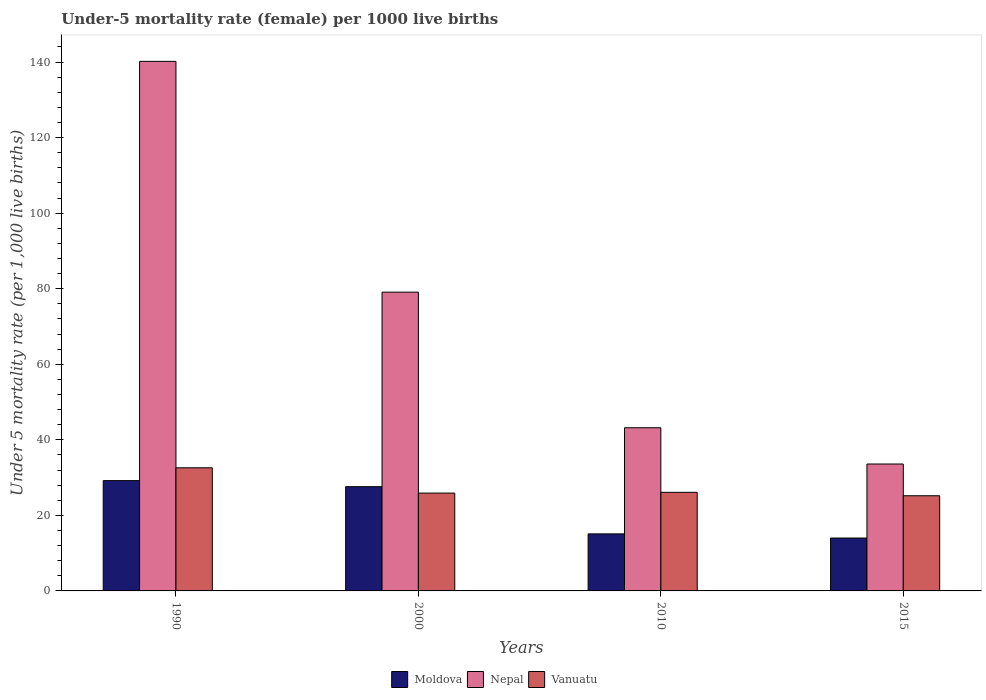How many bars are there on the 1st tick from the right?
Offer a very short reply. 3. In how many cases, is the number of bars for a given year not equal to the number of legend labels?
Your response must be concise. 0. What is the under-five mortality rate in Vanuatu in 2000?
Your answer should be very brief. 25.9. Across all years, what is the maximum under-five mortality rate in Vanuatu?
Make the answer very short. 32.6. Across all years, what is the minimum under-five mortality rate in Nepal?
Keep it short and to the point. 33.6. In which year was the under-five mortality rate in Nepal maximum?
Offer a very short reply. 1990. In which year was the under-five mortality rate in Moldova minimum?
Ensure brevity in your answer.  2015. What is the total under-five mortality rate in Vanuatu in the graph?
Your answer should be very brief. 109.8. What is the difference between the under-five mortality rate in Nepal in 1990 and that in 2015?
Keep it short and to the point. 106.6. What is the difference between the under-five mortality rate in Moldova in 2010 and the under-five mortality rate in Vanuatu in 2015?
Your response must be concise. -10.1. What is the average under-five mortality rate in Moldova per year?
Keep it short and to the point. 21.47. In the year 2015, what is the difference between the under-five mortality rate in Vanuatu and under-five mortality rate in Nepal?
Ensure brevity in your answer.  -8.4. What is the ratio of the under-five mortality rate in Moldova in 2000 to that in 2015?
Ensure brevity in your answer.  1.97. What is the difference between the highest and the second highest under-five mortality rate in Moldova?
Provide a succinct answer. 1.6. What is the difference between the highest and the lowest under-five mortality rate in Moldova?
Your answer should be compact. 15.2. In how many years, is the under-five mortality rate in Moldova greater than the average under-five mortality rate in Moldova taken over all years?
Provide a short and direct response. 2. Is the sum of the under-five mortality rate in Nepal in 1990 and 2015 greater than the maximum under-five mortality rate in Vanuatu across all years?
Provide a succinct answer. Yes. What does the 2nd bar from the left in 2015 represents?
Provide a short and direct response. Nepal. What does the 2nd bar from the right in 1990 represents?
Your answer should be very brief. Nepal. Are all the bars in the graph horizontal?
Make the answer very short. No. Are the values on the major ticks of Y-axis written in scientific E-notation?
Offer a terse response. No. Does the graph contain grids?
Give a very brief answer. No. Where does the legend appear in the graph?
Provide a succinct answer. Bottom center. How are the legend labels stacked?
Make the answer very short. Horizontal. What is the title of the graph?
Your response must be concise. Under-5 mortality rate (female) per 1000 live births. Does "Senegal" appear as one of the legend labels in the graph?
Provide a succinct answer. No. What is the label or title of the X-axis?
Offer a terse response. Years. What is the label or title of the Y-axis?
Keep it short and to the point. Under 5 mortality rate (per 1,0 live births). What is the Under 5 mortality rate (per 1,000 live births) in Moldova in 1990?
Offer a terse response. 29.2. What is the Under 5 mortality rate (per 1,000 live births) of Nepal in 1990?
Provide a short and direct response. 140.2. What is the Under 5 mortality rate (per 1,000 live births) in Vanuatu in 1990?
Give a very brief answer. 32.6. What is the Under 5 mortality rate (per 1,000 live births) of Moldova in 2000?
Your answer should be very brief. 27.6. What is the Under 5 mortality rate (per 1,000 live births) in Nepal in 2000?
Ensure brevity in your answer.  79.1. What is the Under 5 mortality rate (per 1,000 live births) of Vanuatu in 2000?
Give a very brief answer. 25.9. What is the Under 5 mortality rate (per 1,000 live births) in Nepal in 2010?
Your answer should be very brief. 43.2. What is the Under 5 mortality rate (per 1,000 live births) in Vanuatu in 2010?
Keep it short and to the point. 26.1. What is the Under 5 mortality rate (per 1,000 live births) of Moldova in 2015?
Provide a succinct answer. 14. What is the Under 5 mortality rate (per 1,000 live births) in Nepal in 2015?
Provide a short and direct response. 33.6. What is the Under 5 mortality rate (per 1,000 live births) in Vanuatu in 2015?
Provide a short and direct response. 25.2. Across all years, what is the maximum Under 5 mortality rate (per 1,000 live births) in Moldova?
Ensure brevity in your answer.  29.2. Across all years, what is the maximum Under 5 mortality rate (per 1,000 live births) of Nepal?
Give a very brief answer. 140.2. Across all years, what is the maximum Under 5 mortality rate (per 1,000 live births) in Vanuatu?
Keep it short and to the point. 32.6. Across all years, what is the minimum Under 5 mortality rate (per 1,000 live births) in Nepal?
Offer a very short reply. 33.6. Across all years, what is the minimum Under 5 mortality rate (per 1,000 live births) of Vanuatu?
Offer a terse response. 25.2. What is the total Under 5 mortality rate (per 1,000 live births) in Moldova in the graph?
Keep it short and to the point. 85.9. What is the total Under 5 mortality rate (per 1,000 live births) in Nepal in the graph?
Make the answer very short. 296.1. What is the total Under 5 mortality rate (per 1,000 live births) of Vanuatu in the graph?
Your response must be concise. 109.8. What is the difference between the Under 5 mortality rate (per 1,000 live births) in Nepal in 1990 and that in 2000?
Provide a succinct answer. 61.1. What is the difference between the Under 5 mortality rate (per 1,000 live births) of Moldova in 1990 and that in 2010?
Provide a succinct answer. 14.1. What is the difference between the Under 5 mortality rate (per 1,000 live births) of Nepal in 1990 and that in 2010?
Offer a terse response. 97. What is the difference between the Under 5 mortality rate (per 1,000 live births) in Vanuatu in 1990 and that in 2010?
Provide a short and direct response. 6.5. What is the difference between the Under 5 mortality rate (per 1,000 live births) of Moldova in 1990 and that in 2015?
Give a very brief answer. 15.2. What is the difference between the Under 5 mortality rate (per 1,000 live births) of Nepal in 1990 and that in 2015?
Provide a short and direct response. 106.6. What is the difference between the Under 5 mortality rate (per 1,000 live births) in Vanuatu in 1990 and that in 2015?
Give a very brief answer. 7.4. What is the difference between the Under 5 mortality rate (per 1,000 live births) of Moldova in 2000 and that in 2010?
Provide a succinct answer. 12.5. What is the difference between the Under 5 mortality rate (per 1,000 live births) in Nepal in 2000 and that in 2010?
Offer a terse response. 35.9. What is the difference between the Under 5 mortality rate (per 1,000 live births) of Vanuatu in 2000 and that in 2010?
Your answer should be compact. -0.2. What is the difference between the Under 5 mortality rate (per 1,000 live births) of Nepal in 2000 and that in 2015?
Offer a terse response. 45.5. What is the difference between the Under 5 mortality rate (per 1,000 live births) in Moldova in 1990 and the Under 5 mortality rate (per 1,000 live births) in Nepal in 2000?
Ensure brevity in your answer.  -49.9. What is the difference between the Under 5 mortality rate (per 1,000 live births) of Moldova in 1990 and the Under 5 mortality rate (per 1,000 live births) of Vanuatu in 2000?
Make the answer very short. 3.3. What is the difference between the Under 5 mortality rate (per 1,000 live births) of Nepal in 1990 and the Under 5 mortality rate (per 1,000 live births) of Vanuatu in 2000?
Provide a succinct answer. 114.3. What is the difference between the Under 5 mortality rate (per 1,000 live births) of Moldova in 1990 and the Under 5 mortality rate (per 1,000 live births) of Vanuatu in 2010?
Your answer should be compact. 3.1. What is the difference between the Under 5 mortality rate (per 1,000 live births) in Nepal in 1990 and the Under 5 mortality rate (per 1,000 live births) in Vanuatu in 2010?
Keep it short and to the point. 114.1. What is the difference between the Under 5 mortality rate (per 1,000 live births) of Moldova in 1990 and the Under 5 mortality rate (per 1,000 live births) of Vanuatu in 2015?
Offer a very short reply. 4. What is the difference between the Under 5 mortality rate (per 1,000 live births) of Nepal in 1990 and the Under 5 mortality rate (per 1,000 live births) of Vanuatu in 2015?
Your answer should be very brief. 115. What is the difference between the Under 5 mortality rate (per 1,000 live births) in Moldova in 2000 and the Under 5 mortality rate (per 1,000 live births) in Nepal in 2010?
Offer a very short reply. -15.6. What is the difference between the Under 5 mortality rate (per 1,000 live births) of Nepal in 2000 and the Under 5 mortality rate (per 1,000 live births) of Vanuatu in 2010?
Keep it short and to the point. 53. What is the difference between the Under 5 mortality rate (per 1,000 live births) in Nepal in 2000 and the Under 5 mortality rate (per 1,000 live births) in Vanuatu in 2015?
Your answer should be compact. 53.9. What is the difference between the Under 5 mortality rate (per 1,000 live births) in Moldova in 2010 and the Under 5 mortality rate (per 1,000 live births) in Nepal in 2015?
Your answer should be compact. -18.5. What is the average Under 5 mortality rate (per 1,000 live births) in Moldova per year?
Ensure brevity in your answer.  21.48. What is the average Under 5 mortality rate (per 1,000 live births) of Nepal per year?
Offer a terse response. 74.03. What is the average Under 5 mortality rate (per 1,000 live births) of Vanuatu per year?
Provide a succinct answer. 27.45. In the year 1990, what is the difference between the Under 5 mortality rate (per 1,000 live births) in Moldova and Under 5 mortality rate (per 1,000 live births) in Nepal?
Give a very brief answer. -111. In the year 1990, what is the difference between the Under 5 mortality rate (per 1,000 live births) of Moldova and Under 5 mortality rate (per 1,000 live births) of Vanuatu?
Provide a short and direct response. -3.4. In the year 1990, what is the difference between the Under 5 mortality rate (per 1,000 live births) of Nepal and Under 5 mortality rate (per 1,000 live births) of Vanuatu?
Your answer should be very brief. 107.6. In the year 2000, what is the difference between the Under 5 mortality rate (per 1,000 live births) of Moldova and Under 5 mortality rate (per 1,000 live births) of Nepal?
Offer a very short reply. -51.5. In the year 2000, what is the difference between the Under 5 mortality rate (per 1,000 live births) in Nepal and Under 5 mortality rate (per 1,000 live births) in Vanuatu?
Your answer should be very brief. 53.2. In the year 2010, what is the difference between the Under 5 mortality rate (per 1,000 live births) of Moldova and Under 5 mortality rate (per 1,000 live births) of Nepal?
Offer a terse response. -28.1. In the year 2010, what is the difference between the Under 5 mortality rate (per 1,000 live births) of Moldova and Under 5 mortality rate (per 1,000 live births) of Vanuatu?
Give a very brief answer. -11. In the year 2015, what is the difference between the Under 5 mortality rate (per 1,000 live births) of Moldova and Under 5 mortality rate (per 1,000 live births) of Nepal?
Keep it short and to the point. -19.6. In the year 2015, what is the difference between the Under 5 mortality rate (per 1,000 live births) in Moldova and Under 5 mortality rate (per 1,000 live births) in Vanuatu?
Offer a terse response. -11.2. In the year 2015, what is the difference between the Under 5 mortality rate (per 1,000 live births) of Nepal and Under 5 mortality rate (per 1,000 live births) of Vanuatu?
Keep it short and to the point. 8.4. What is the ratio of the Under 5 mortality rate (per 1,000 live births) of Moldova in 1990 to that in 2000?
Keep it short and to the point. 1.06. What is the ratio of the Under 5 mortality rate (per 1,000 live births) in Nepal in 1990 to that in 2000?
Make the answer very short. 1.77. What is the ratio of the Under 5 mortality rate (per 1,000 live births) of Vanuatu in 1990 to that in 2000?
Provide a succinct answer. 1.26. What is the ratio of the Under 5 mortality rate (per 1,000 live births) of Moldova in 1990 to that in 2010?
Your answer should be compact. 1.93. What is the ratio of the Under 5 mortality rate (per 1,000 live births) in Nepal in 1990 to that in 2010?
Offer a terse response. 3.25. What is the ratio of the Under 5 mortality rate (per 1,000 live births) of Vanuatu in 1990 to that in 2010?
Provide a short and direct response. 1.25. What is the ratio of the Under 5 mortality rate (per 1,000 live births) of Moldova in 1990 to that in 2015?
Your response must be concise. 2.09. What is the ratio of the Under 5 mortality rate (per 1,000 live births) of Nepal in 1990 to that in 2015?
Your answer should be very brief. 4.17. What is the ratio of the Under 5 mortality rate (per 1,000 live births) in Vanuatu in 1990 to that in 2015?
Make the answer very short. 1.29. What is the ratio of the Under 5 mortality rate (per 1,000 live births) in Moldova in 2000 to that in 2010?
Your response must be concise. 1.83. What is the ratio of the Under 5 mortality rate (per 1,000 live births) of Nepal in 2000 to that in 2010?
Keep it short and to the point. 1.83. What is the ratio of the Under 5 mortality rate (per 1,000 live births) of Vanuatu in 2000 to that in 2010?
Offer a terse response. 0.99. What is the ratio of the Under 5 mortality rate (per 1,000 live births) of Moldova in 2000 to that in 2015?
Your answer should be compact. 1.97. What is the ratio of the Under 5 mortality rate (per 1,000 live births) in Nepal in 2000 to that in 2015?
Offer a very short reply. 2.35. What is the ratio of the Under 5 mortality rate (per 1,000 live births) in Vanuatu in 2000 to that in 2015?
Your answer should be compact. 1.03. What is the ratio of the Under 5 mortality rate (per 1,000 live births) in Moldova in 2010 to that in 2015?
Offer a very short reply. 1.08. What is the ratio of the Under 5 mortality rate (per 1,000 live births) of Vanuatu in 2010 to that in 2015?
Your response must be concise. 1.04. What is the difference between the highest and the second highest Under 5 mortality rate (per 1,000 live births) in Moldova?
Your response must be concise. 1.6. What is the difference between the highest and the second highest Under 5 mortality rate (per 1,000 live births) in Nepal?
Offer a very short reply. 61.1. What is the difference between the highest and the lowest Under 5 mortality rate (per 1,000 live births) in Nepal?
Ensure brevity in your answer.  106.6. 